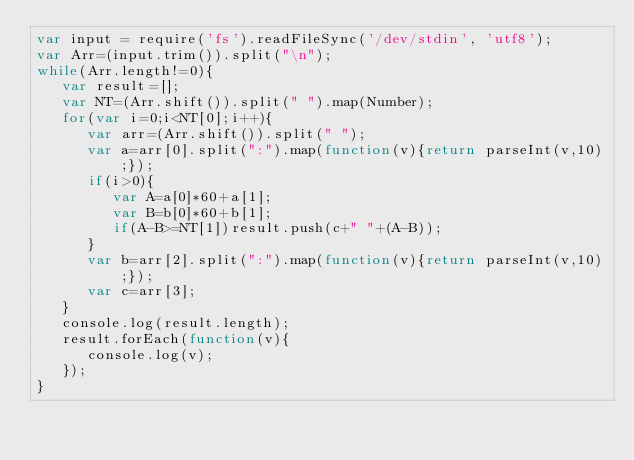<code> <loc_0><loc_0><loc_500><loc_500><_JavaScript_>var input = require('fs').readFileSync('/dev/stdin', 'utf8');
var Arr=(input.trim()).split("\n");
while(Arr.length!=0){
   var result=[];
   var NT=(Arr.shift()).split(" ").map(Number);
   for(var i=0;i<NT[0];i++){
      var arr=(Arr.shift()).split(" ");
      var a=arr[0].split(":").map(function(v){return parseInt(v,10);});
      if(i>0){
         var A=a[0]*60+a[1];
         var B=b[0]*60+b[1];
         if(A-B>=NT[1])result.push(c+" "+(A-B));
      }
      var b=arr[2].split(":").map(function(v){return parseInt(v,10);});
      var c=arr[3];
   }
   console.log(result.length);
   result.forEach(function(v){
      console.log(v);
   });
}</code> 